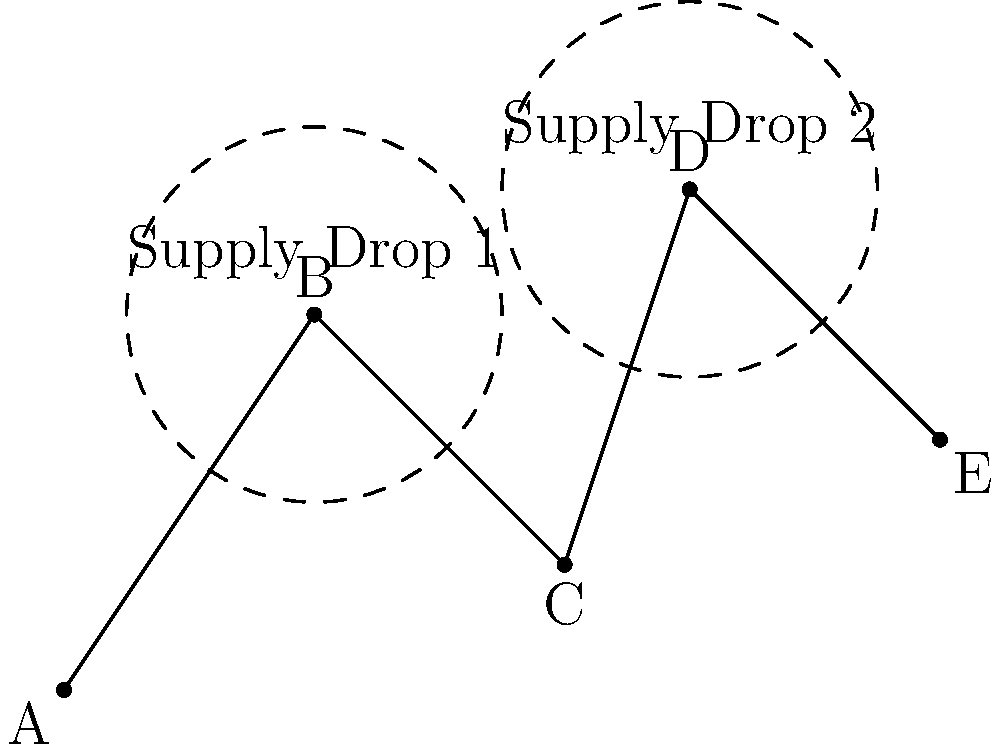In a tactical operation, you need to determine the minimum number of supply drops required to reach all units in a given area. The units are positioned at points A, B, C, D, and E, as shown in the diagram. Each supply drop has a coverage radius of 1.5 units. What is the minimum number of supply drops needed to ensure all units receive supplies? To solve this problem, we need to follow these steps:

1. Analyze the positions of the units:
   - Unit A: (0,0)
   - Unit B: (2,3)
   - Unit C: (4,1)
   - Unit D: (5,4)
   - Unit E: (7,2)

2. Consider the coverage radius of each supply drop (1.5 units).

3. Determine the optimal placement of supply drops:
   a. Place the first supply drop at point B (2,3):
      - This covers units A and B.
      - The coverage circle extends 1.5 units in all directions from B.

   b. Place the second supply drop at point D (5,4):
      - This covers units C, D, and E.
      - The coverage circle extends 1.5 units in all directions from D.

4. Verify that all units are covered:
   - Units A and B are covered by the first supply drop.
   - Units C, D, and E are covered by the second supply drop.

5. Count the number of supply drops used:
   - We used 2 supply drops to cover all units.

6. Check if it's possible to cover all units with fewer drops:
   - It's not possible to cover all units with just one drop due to the distance between the units.

Therefore, the minimum number of supply drops needed is 2.
Answer: 2 supply drops 